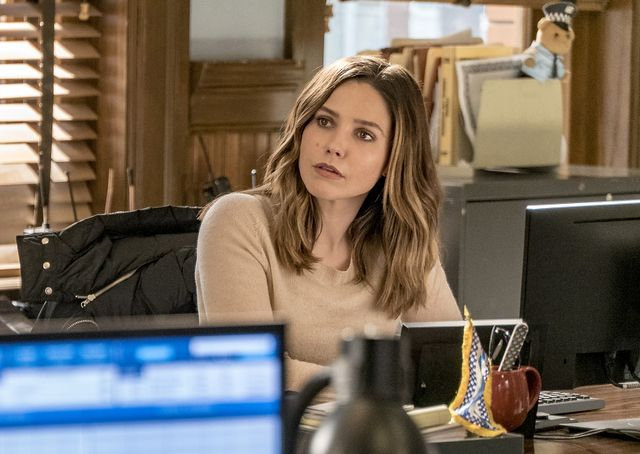What details can you tell me about the setting of this image? This appears to be an indoor office setting, identified by typical workspace features like the computer monitor, a bulletin board, and office supplies. The room is illuminated by both artificial desk lamp light and daylight, suggesting an active workday environment. Personal touches like a patterned mug add a sense of individuality to the workspace. 